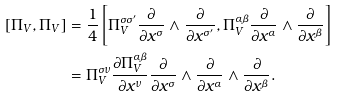Convert formula to latex. <formula><loc_0><loc_0><loc_500><loc_500>[ \Pi _ { V } , \Pi _ { V } ] & = \frac { 1 } { 4 } \left [ \Pi _ { V } ^ { \sigma \sigma ^ { \prime } } \frac { \partial } { \partial x ^ { \sigma } } \wedge \frac { \partial } { \partial x ^ { \sigma ^ { \prime } } } , \Pi _ { V } ^ { \alpha \beta } \frac { \partial } { \partial x ^ { \alpha } } \wedge \frac { \partial } { \partial x ^ { \beta } } \right ] \\ & = \Pi _ { V } ^ { \sigma \nu } \frac { \partial \Pi _ { V } ^ { \alpha \beta } } { \partial x ^ { \nu } } \frac { \partial } { \partial x ^ { \sigma } } \wedge \frac { \partial } { \partial x ^ { \alpha } } \wedge \frac { \partial } { \partial x ^ { \beta } } .</formula> 